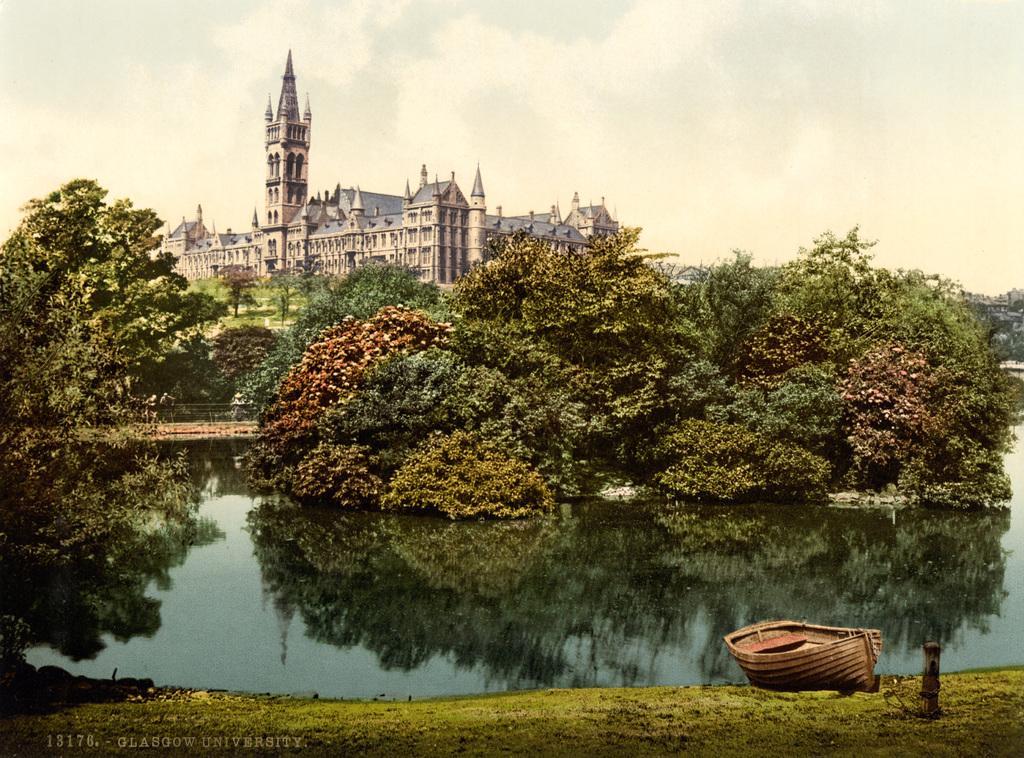In one or two sentences, can you explain what this image depicts? In this image I can see a boat and water. Back Side I can see trees,building and windows. The sky is in white color. 